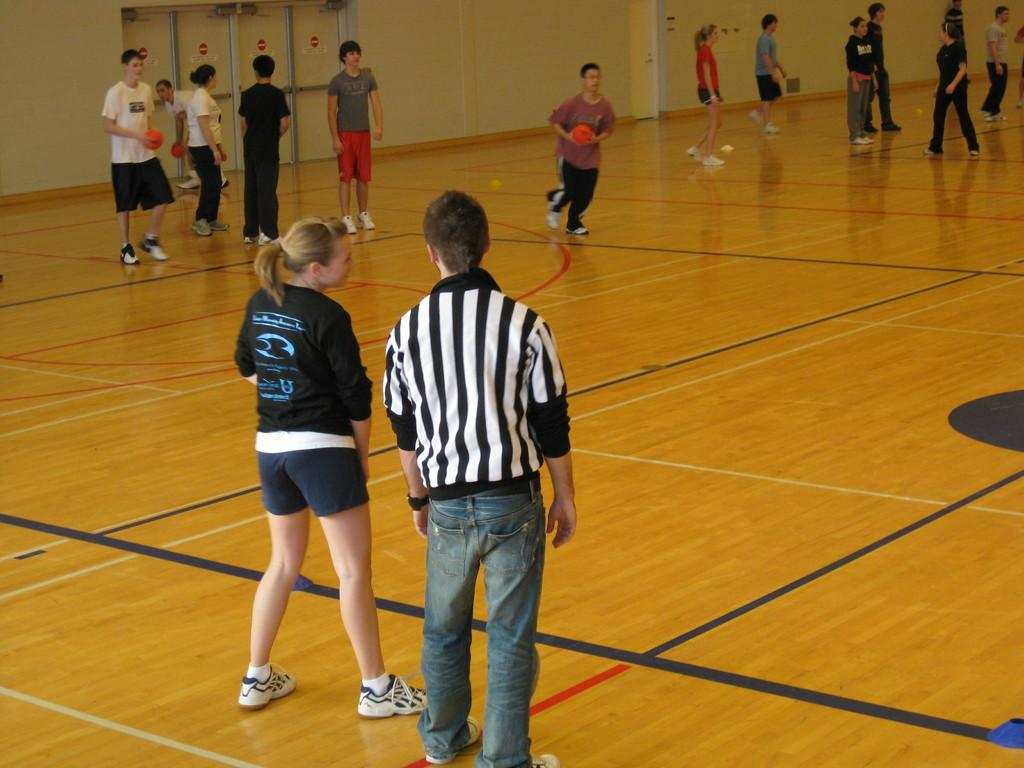What activity are the people in the image engaged in? The people in the image are playing a game. What objects are being used in the game? Some of the people are holding balls. What can be seen in the background of the image? There is a wall in the background of the image. What type of crack can be seen on the wall in the image? There is no crack visible on the wall in the image. What kind of marble is being used in the game? There is no marble being used in the game; the people are holding balls. 